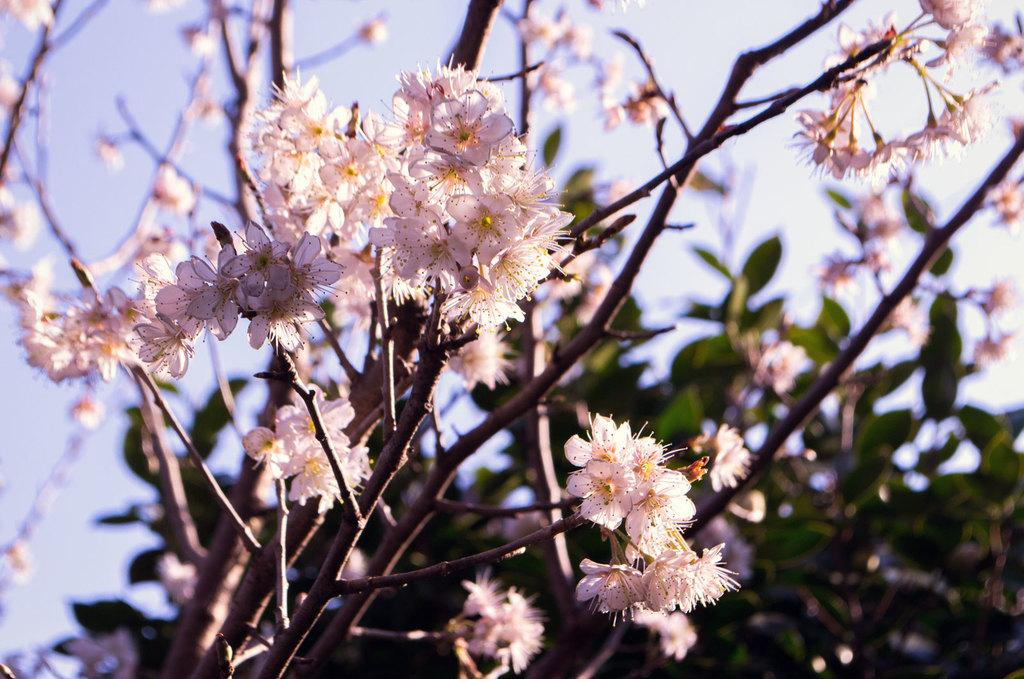What type of vegetation can be seen in the image? There are trees in the image. What other natural elements are present in the image? There are flowers in the image. How would you describe the weather based on the image? The sky is cloudy in the image, suggesting a potentially overcast or rainy day. What is the name of the town where the flowers are located in the image? There is no town mentioned or visible in the image, so it cannot be determined from the image alone. 